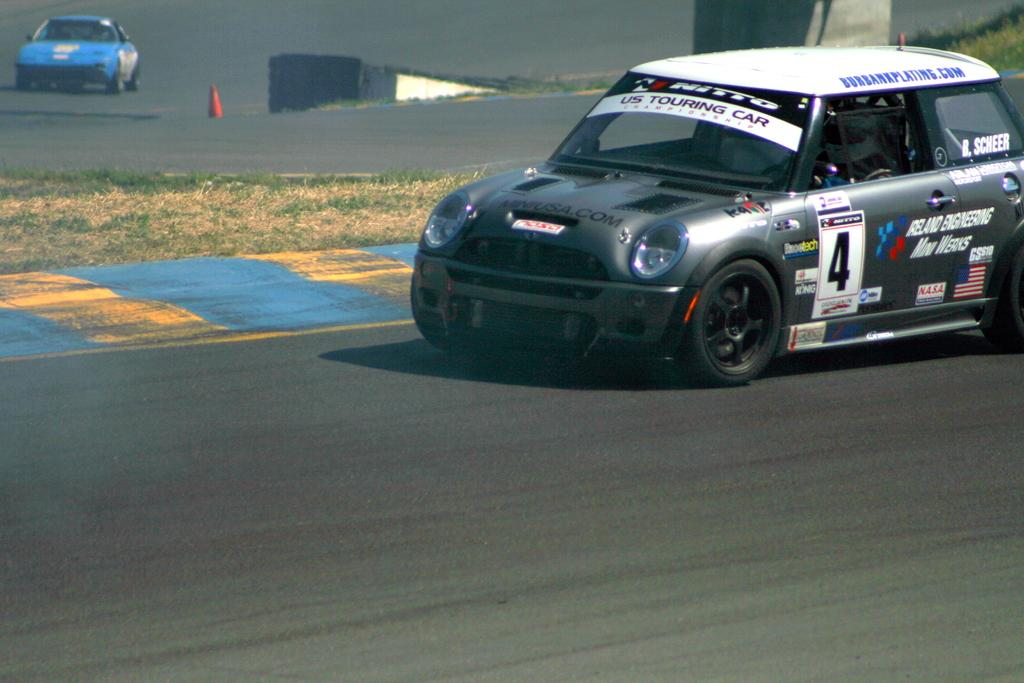How many cars are visible on the road in the image? There are two cars on the road in the image. What can be seen on the left side of the image? There is a grassland on the left side of the image. What object is on the road in the image? There is an inverted cone on the road in the image. Where is the pillar located in the image? There is a pillar in the top right corner of the image. What type of nut is being used to power the cars in the image? There is no nut present in the image, and the cars are not powered by nuts. What appliance is being used to destroy the grassland in the image? There is no appliance or destruction present in the image; it features two cars on the road, an inverted cone, and a pillar. 